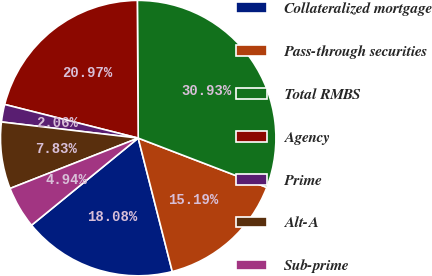Convert chart. <chart><loc_0><loc_0><loc_500><loc_500><pie_chart><fcel>Collateralized mortgage<fcel>Pass-through securities<fcel>Total RMBS<fcel>Agency<fcel>Prime<fcel>Alt-A<fcel>Sub-prime<nl><fcel>18.08%<fcel>15.19%<fcel>30.93%<fcel>20.97%<fcel>2.06%<fcel>7.83%<fcel>4.94%<nl></chart> 